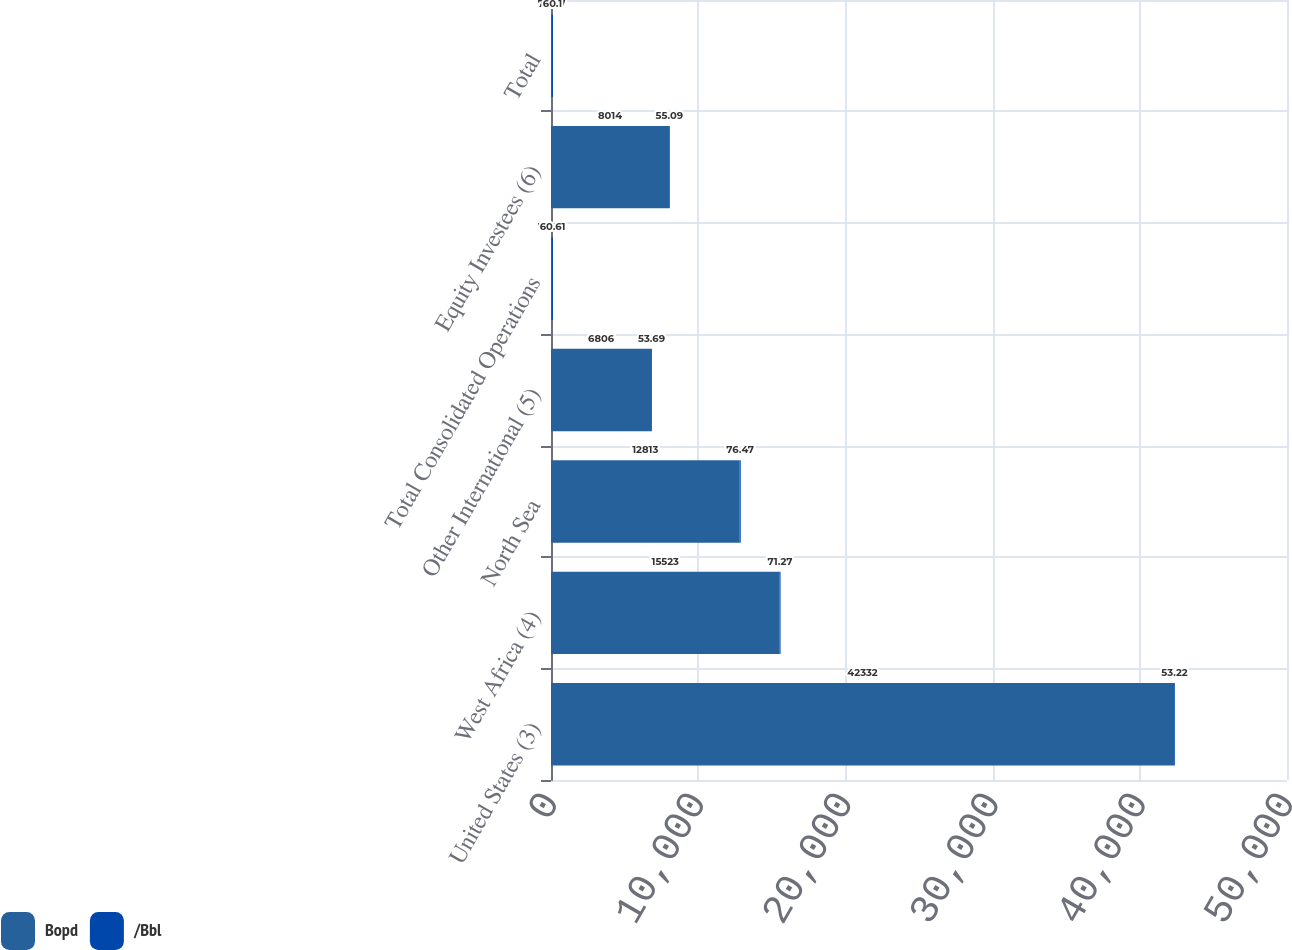Convert chart. <chart><loc_0><loc_0><loc_500><loc_500><stacked_bar_chart><ecel><fcel>United States (3)<fcel>West Africa (4)<fcel>North Sea<fcel>Other International (5)<fcel>Total Consolidated Operations<fcel>Equity Investees (6)<fcel>Total<nl><fcel>Bopd<fcel>42332<fcel>15523<fcel>12813<fcel>6806<fcel>73.87<fcel>8014<fcel>73.87<nl><fcel>/Bbl<fcel>53.22<fcel>71.27<fcel>76.47<fcel>53.69<fcel>60.61<fcel>55.09<fcel>60.1<nl></chart> 